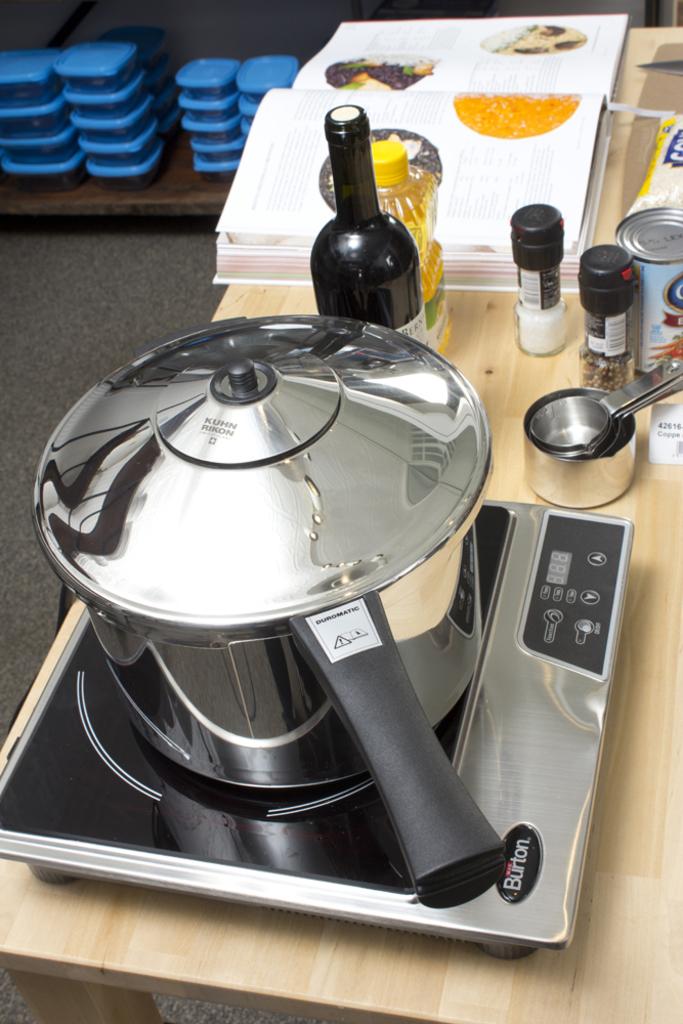Isn't that smithsonian museum?
Your answer should be very brief. Unanswerable. 